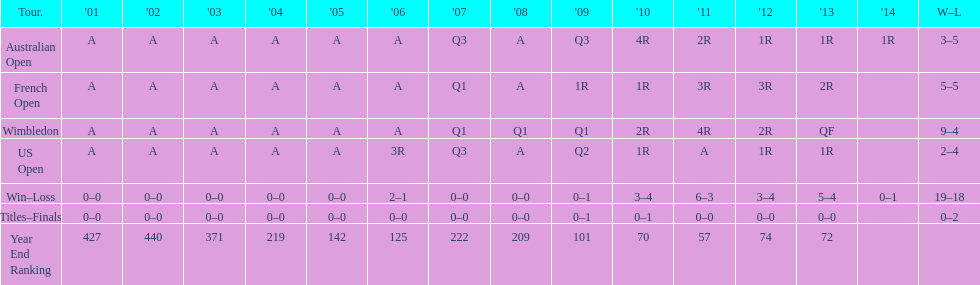In what years was a ranking beneath 200 attained? 2005, 2006, 2009, 2010, 2011, 2012, 2013. 